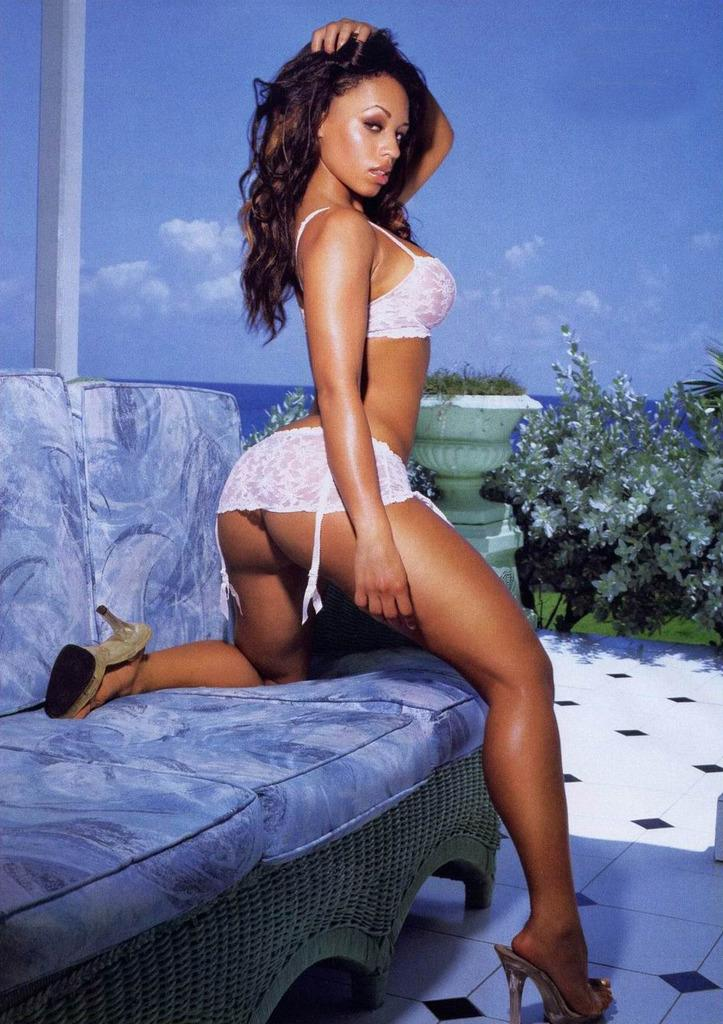Who is the main subject in the image? There is a woman in the image. What is the woman doing in the image? The woman has placed one leg on a sofa. What can be seen in the background of the image? There are flower pots in the background of the image. What type of coal is being used to fuel the fire in the image? There is no fire or coal present in the image; it features a woman with one leg on a sofa and flower pots in the background. 